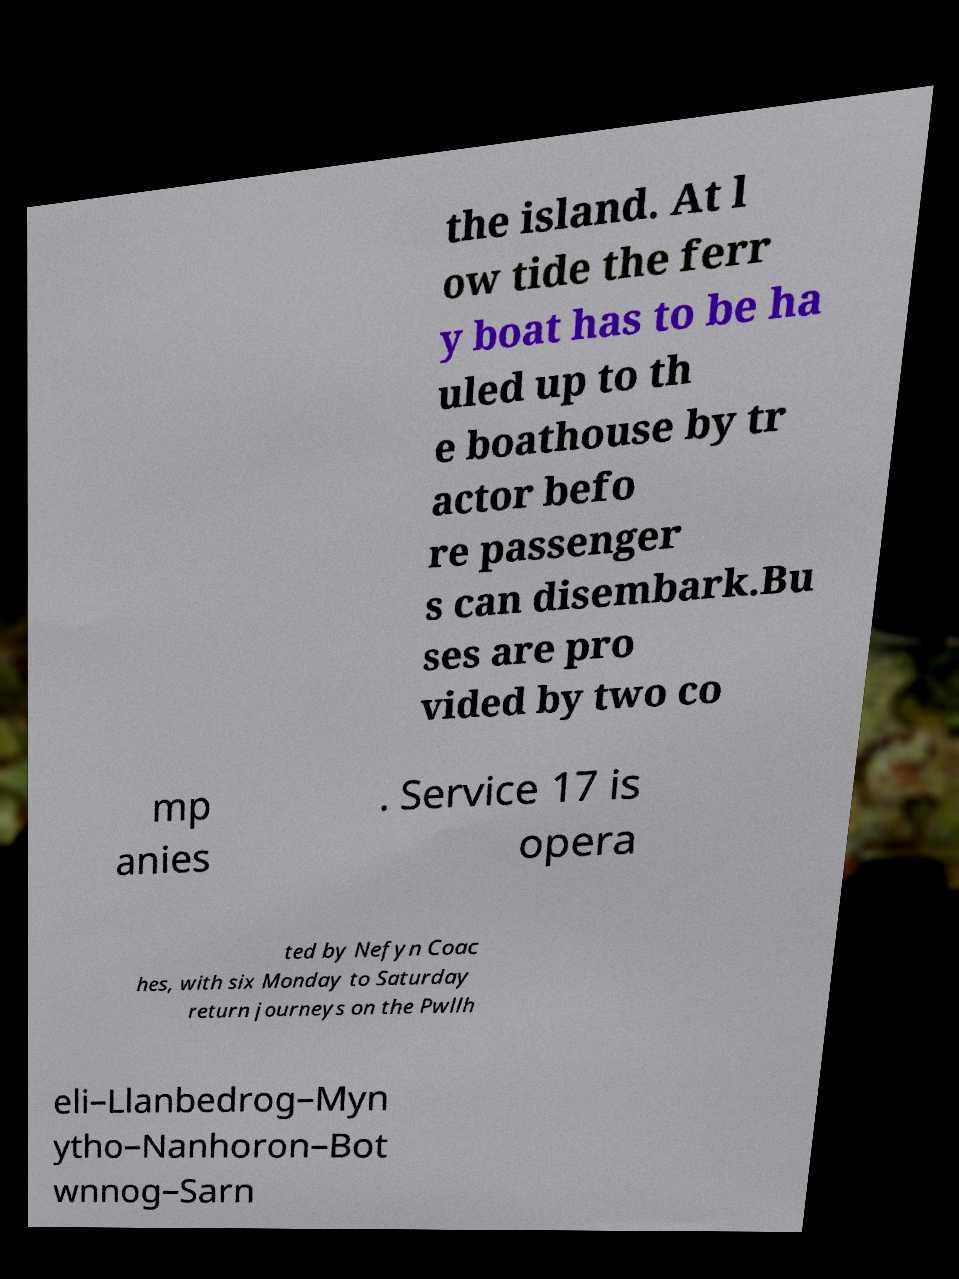Please read and relay the text visible in this image. What does it say? the island. At l ow tide the ferr y boat has to be ha uled up to th e boathouse by tr actor befo re passenger s can disembark.Bu ses are pro vided by two co mp anies . Service 17 is opera ted by Nefyn Coac hes, with six Monday to Saturday return journeys on the Pwllh eli–Llanbedrog–Myn ytho–Nanhoron–Bot wnnog–Sarn 